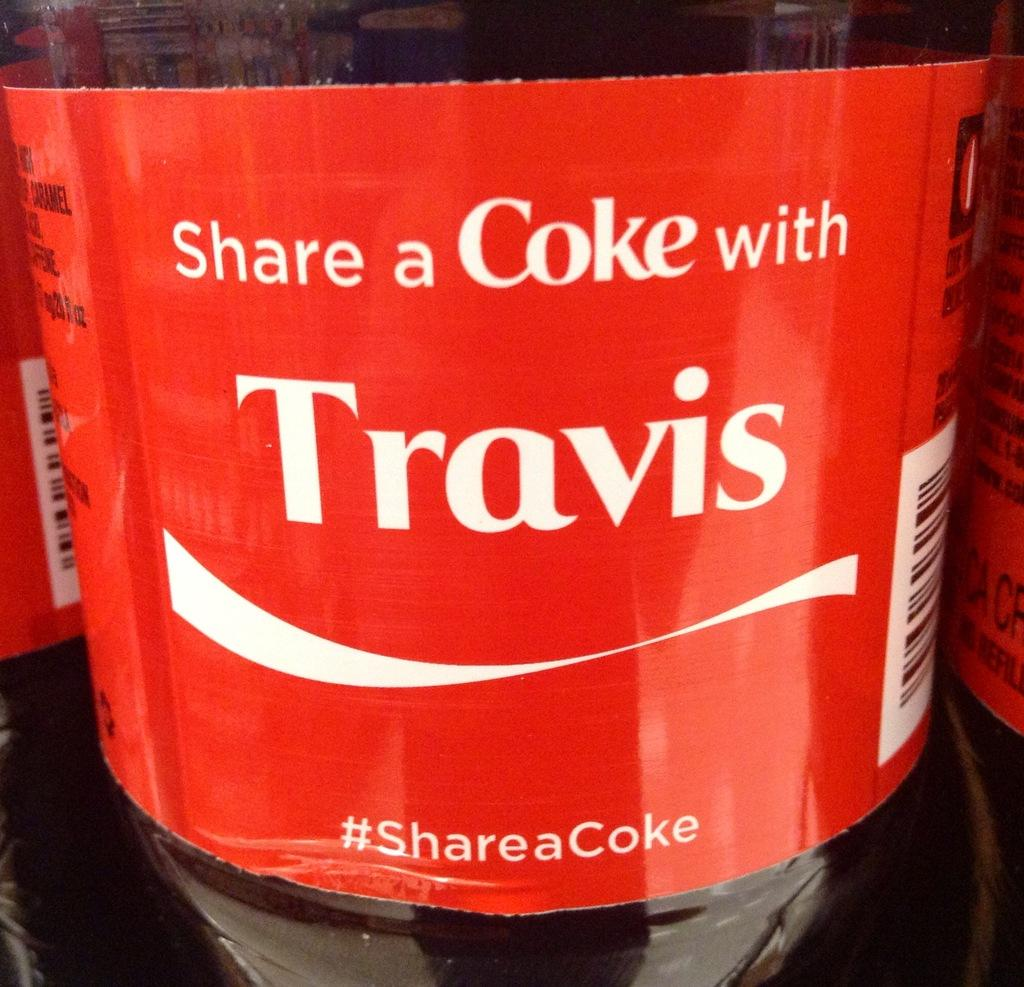<image>
Share a concise interpretation of the image provided. a close up of a Coke label reading Share a Coke with Travis 